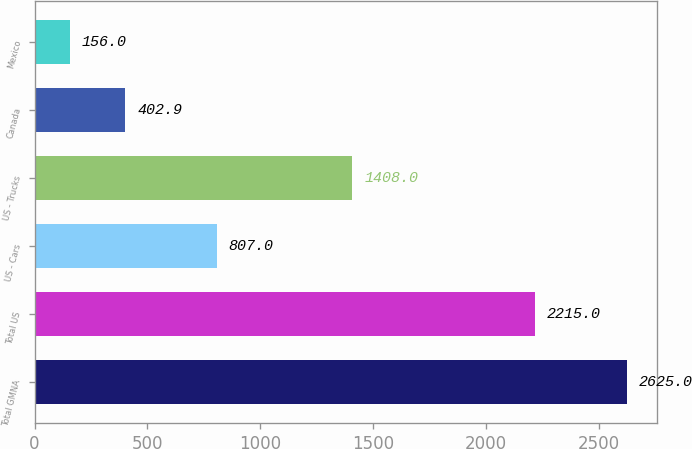Convert chart. <chart><loc_0><loc_0><loc_500><loc_500><bar_chart><fcel>Total GMNA<fcel>Total US<fcel>US - Cars<fcel>US - Trucks<fcel>Canada<fcel>Mexico<nl><fcel>2625<fcel>2215<fcel>807<fcel>1408<fcel>402.9<fcel>156<nl></chart> 